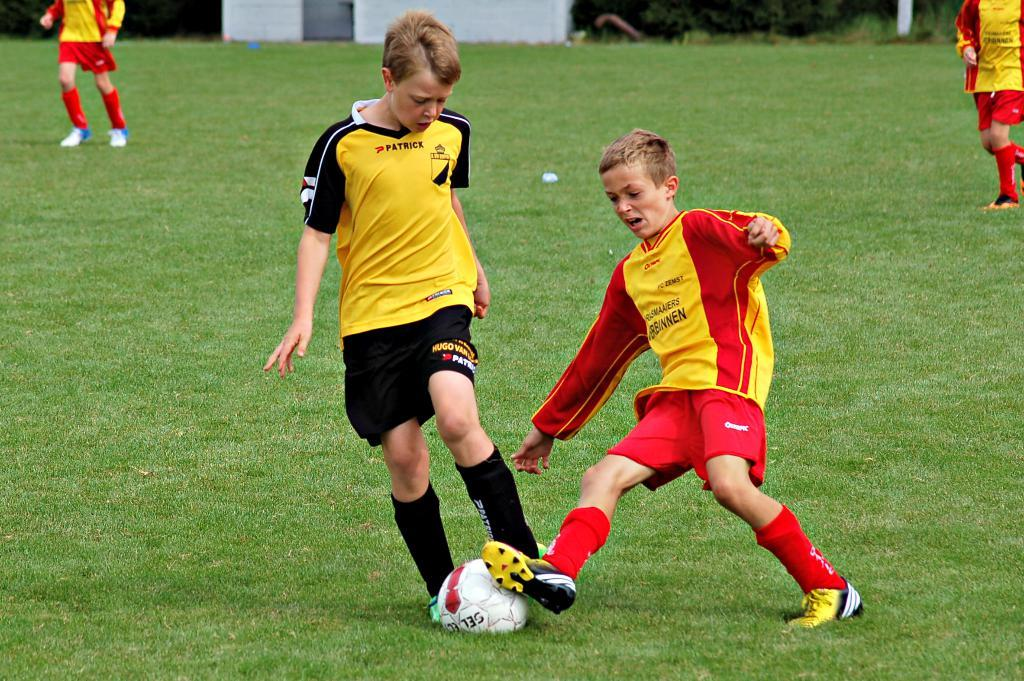How many people are in the image? There are two persons in the image. What are the two persons doing in the image? The two persons are playing with a ball. What type of surface can be seen in the image? The ground is visible in the image. What kind of vegetation is present in the image? There is grass in the image. What religion is being practiced by the two persons in the image? There is no indication of any religious activity or belief in the image; the two persons are simply playing with a ball. 